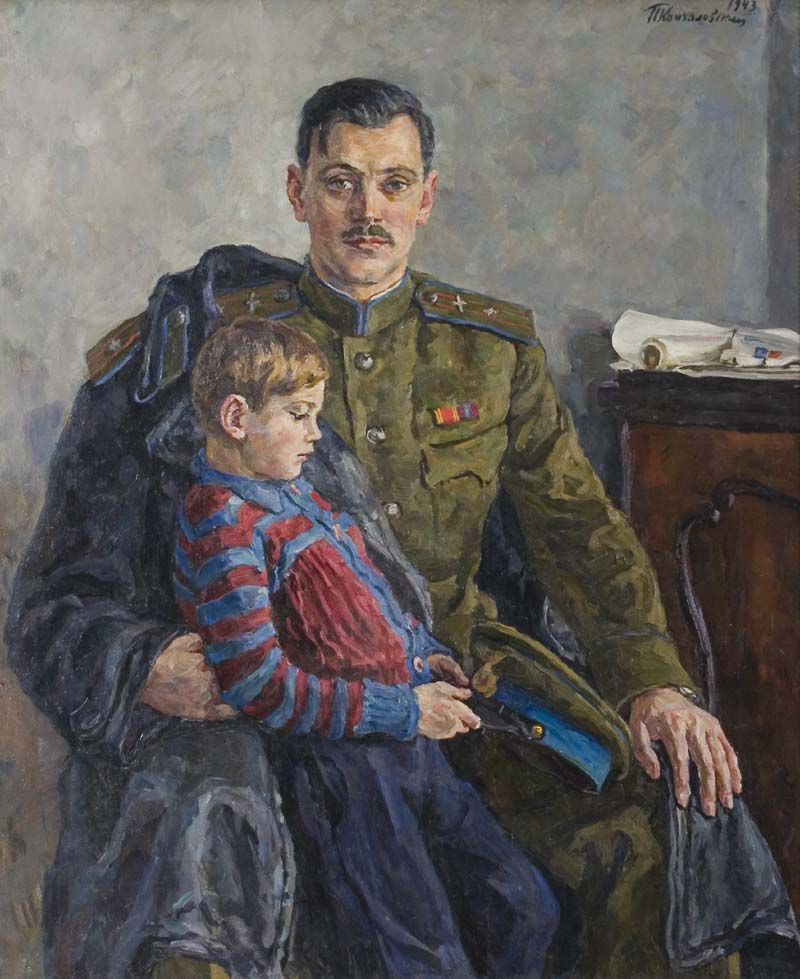Describe a longer realistic scenario involving both the man and the boy based on this painting. One chilly morning, the man in the green military uniform prepares for another day at the base. The house is silent save for the soft rustle of papers on the desk. His young son, adorned in his favorite red and blue striped shirt, tiptoes in and quietly sits on his father's lap, offering comfort in the early hour. The father gently wraps his coat around the boy, sharing warmth in more ways than one. As the father adjusts the medals on his chest, he explains their meanings to his curious son, using the stories as lessons of bravery, honor, and the realities of life. They laugh about shared memories and ponder the future. The man then reveals a small gift—a sketchbook and a box of charcoal—nudging his son toward a path of creativity. The boy is delighted, promising to draw them together every day. As the sunlight starts to seep through the window, a sense of peace envelops the room, knitting their bond closer. This serene morning shared between father and son would hold a special place in their heart, especially as the father prepares for his day ahead, leaving behind a piece of himself in the tender moments they crafted together. 